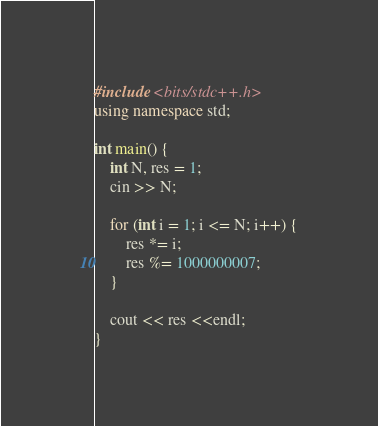Convert code to text. <code><loc_0><loc_0><loc_500><loc_500><_C++_>#include <bits/stdc++.h>
using namespace std;

int main() {
    int N, res = 1;
    cin >> N;

    for (int i = 1; i <= N; i++) {
        res *= i;
        res %= 1000000007;
    }

    cout << res <<endl;
}</code> 